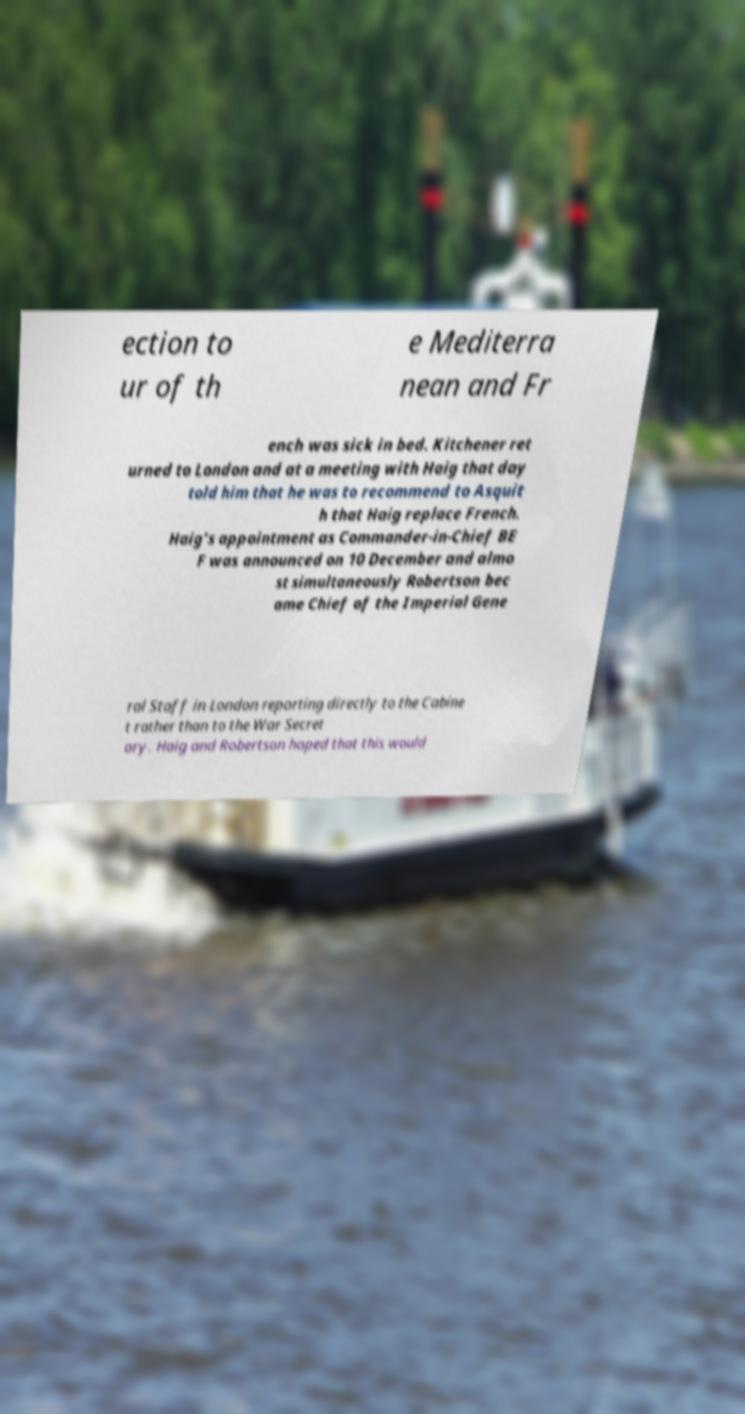Could you assist in decoding the text presented in this image and type it out clearly? ection to ur of th e Mediterra nean and Fr ench was sick in bed. Kitchener ret urned to London and at a meeting with Haig that day told him that he was to recommend to Asquit h that Haig replace French. Haig's appointment as Commander-in-Chief BE F was announced on 10 December and almo st simultaneously Robertson bec ame Chief of the Imperial Gene ral Staff in London reporting directly to the Cabine t rather than to the War Secret ary. Haig and Robertson hoped that this would 